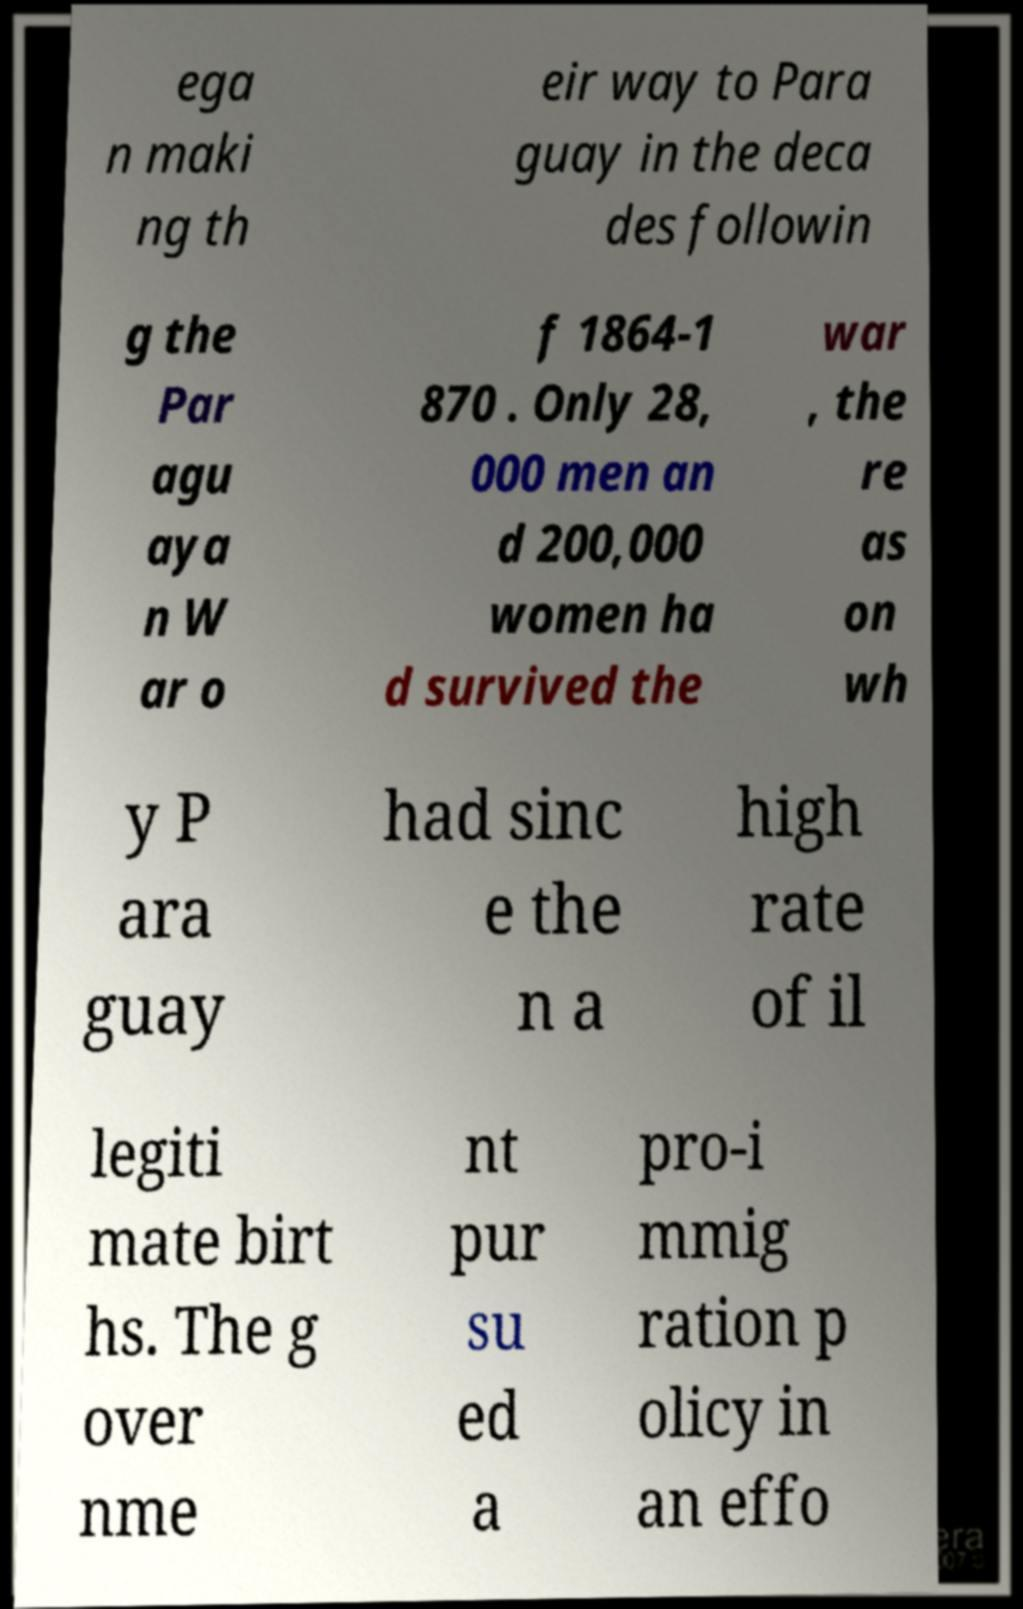I need the written content from this picture converted into text. Can you do that? ega n maki ng th eir way to Para guay in the deca des followin g the Par agu aya n W ar o f 1864-1 870 . Only 28, 000 men an d 200,000 women ha d survived the war , the re as on wh y P ara guay had sinc e the n a high rate of il legiti mate birt hs. The g over nme nt pur su ed a pro-i mmig ration p olicy in an effo 